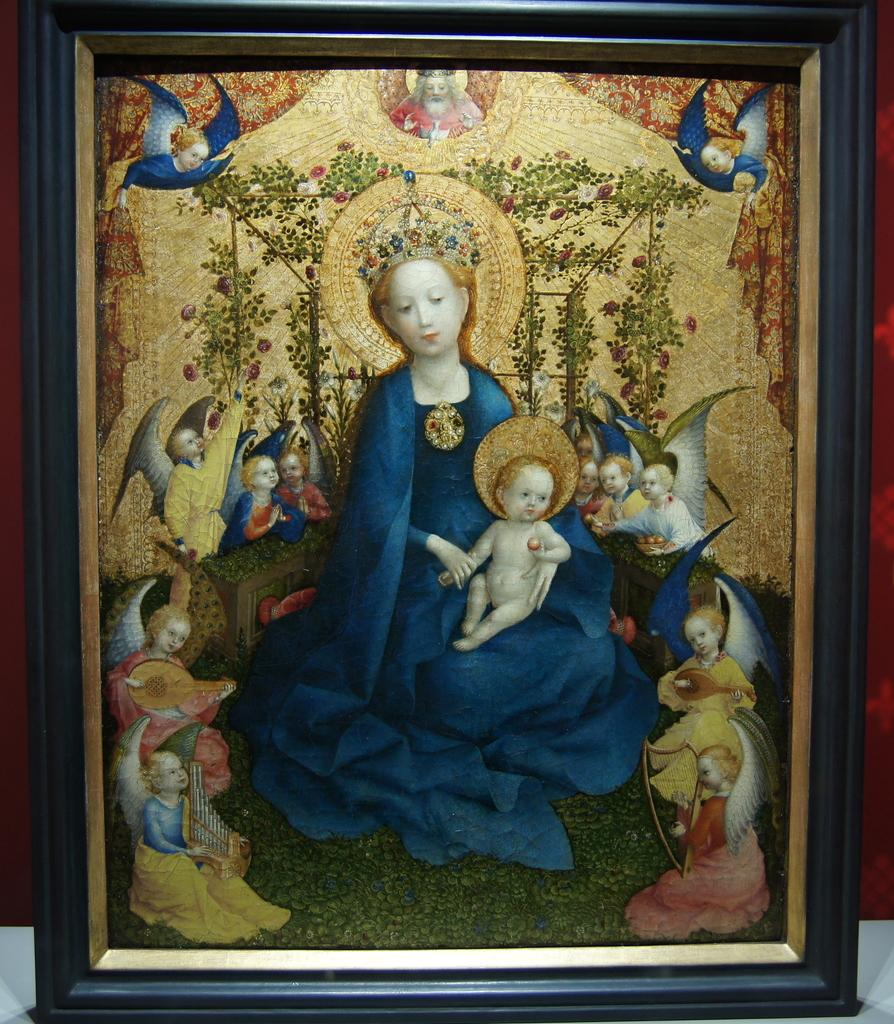What object is present in the image that typically holds a visual representation? There is a photo frame in the image. What is displayed within the photo frame? The photo frame contains a painting. What is the subject matter of the painting? The painting depicts persons. Can you describe any specific design elements within the painting? The painting has a design element. What type of bird can be seen flying in the painting? There is no bird present in the painting; it depicts persons. What kind of fuel is being used by the boats in the painting? There are no boats present in the painting; it depicts persons. 